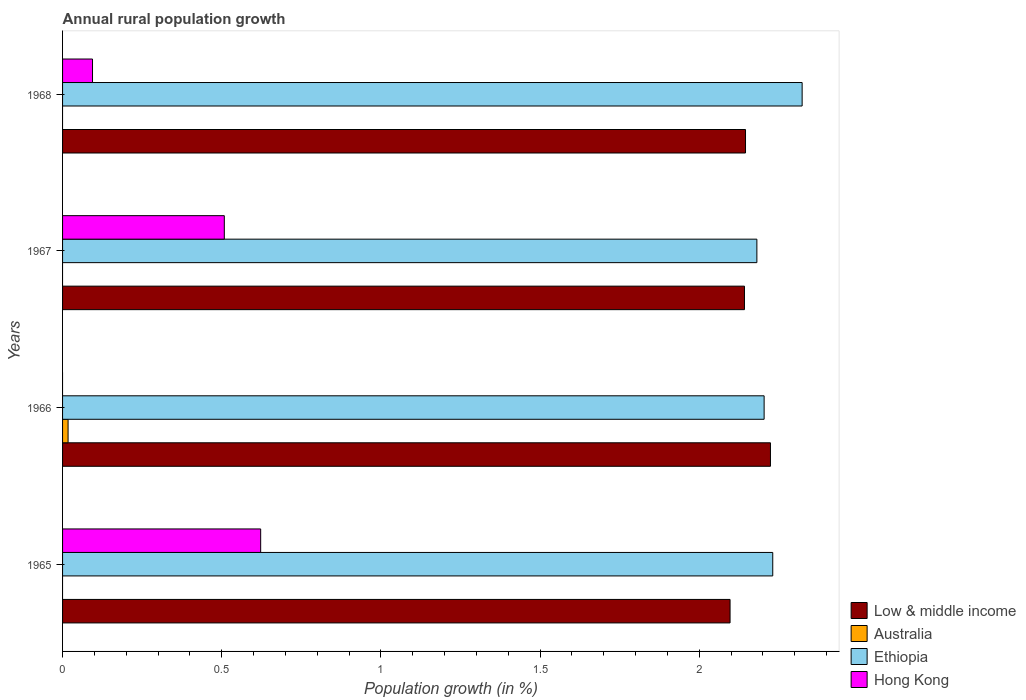How many different coloured bars are there?
Provide a succinct answer. 4. Are the number of bars per tick equal to the number of legend labels?
Offer a terse response. No. Are the number of bars on each tick of the Y-axis equal?
Offer a very short reply. Yes. How many bars are there on the 4th tick from the top?
Your answer should be compact. 3. What is the label of the 3rd group of bars from the top?
Give a very brief answer. 1966. What is the percentage of rural population growth in Ethiopia in 1966?
Give a very brief answer. 2.2. Across all years, what is the maximum percentage of rural population growth in Ethiopia?
Ensure brevity in your answer.  2.32. In which year was the percentage of rural population growth in Australia maximum?
Give a very brief answer. 1966. What is the total percentage of rural population growth in Ethiopia in the graph?
Ensure brevity in your answer.  8.94. What is the difference between the percentage of rural population growth in Low & middle income in 1966 and that in 1968?
Provide a short and direct response. 0.08. What is the difference between the percentage of rural population growth in Hong Kong in 1967 and the percentage of rural population growth in Low & middle income in 1965?
Your response must be concise. -1.59. What is the average percentage of rural population growth in Ethiopia per year?
Offer a very short reply. 2.23. In the year 1968, what is the difference between the percentage of rural population growth in Hong Kong and percentage of rural population growth in Low & middle income?
Ensure brevity in your answer.  -2.05. What is the ratio of the percentage of rural population growth in Hong Kong in 1965 to that in 1968?
Provide a short and direct response. 6.62. What is the difference between the highest and the second highest percentage of rural population growth in Ethiopia?
Your answer should be very brief. 0.09. What is the difference between the highest and the lowest percentage of rural population growth in Hong Kong?
Your response must be concise. 0.62. In how many years, is the percentage of rural population growth in Australia greater than the average percentage of rural population growth in Australia taken over all years?
Ensure brevity in your answer.  1. Is it the case that in every year, the sum of the percentage of rural population growth in Low & middle income and percentage of rural population growth in Ethiopia is greater than the percentage of rural population growth in Hong Kong?
Your response must be concise. Yes. How many years are there in the graph?
Keep it short and to the point. 4. What is the difference between two consecutive major ticks on the X-axis?
Give a very brief answer. 0.5. Does the graph contain any zero values?
Keep it short and to the point. Yes. Where does the legend appear in the graph?
Make the answer very short. Bottom right. How many legend labels are there?
Your response must be concise. 4. What is the title of the graph?
Your answer should be compact. Annual rural population growth. What is the label or title of the X-axis?
Offer a very short reply. Population growth (in %). What is the label or title of the Y-axis?
Your answer should be compact. Years. What is the Population growth (in %) of Low & middle income in 1965?
Your response must be concise. 2.1. What is the Population growth (in %) in Ethiopia in 1965?
Your answer should be very brief. 2.23. What is the Population growth (in %) in Hong Kong in 1965?
Provide a succinct answer. 0.62. What is the Population growth (in %) of Low & middle income in 1966?
Your answer should be compact. 2.22. What is the Population growth (in %) of Australia in 1966?
Your answer should be compact. 0.02. What is the Population growth (in %) in Ethiopia in 1966?
Offer a very short reply. 2.2. What is the Population growth (in %) in Low & middle income in 1967?
Give a very brief answer. 2.14. What is the Population growth (in %) of Australia in 1967?
Keep it short and to the point. 0. What is the Population growth (in %) in Ethiopia in 1967?
Keep it short and to the point. 2.18. What is the Population growth (in %) of Hong Kong in 1967?
Provide a succinct answer. 0.51. What is the Population growth (in %) in Low & middle income in 1968?
Ensure brevity in your answer.  2.15. What is the Population growth (in %) in Australia in 1968?
Give a very brief answer. 0. What is the Population growth (in %) in Ethiopia in 1968?
Offer a very short reply. 2.32. What is the Population growth (in %) of Hong Kong in 1968?
Provide a succinct answer. 0.09. Across all years, what is the maximum Population growth (in %) in Low & middle income?
Offer a very short reply. 2.22. Across all years, what is the maximum Population growth (in %) in Australia?
Keep it short and to the point. 0.02. Across all years, what is the maximum Population growth (in %) in Ethiopia?
Your response must be concise. 2.32. Across all years, what is the maximum Population growth (in %) in Hong Kong?
Offer a terse response. 0.62. Across all years, what is the minimum Population growth (in %) of Low & middle income?
Provide a succinct answer. 2.1. Across all years, what is the minimum Population growth (in %) of Ethiopia?
Your answer should be compact. 2.18. What is the total Population growth (in %) in Low & middle income in the graph?
Ensure brevity in your answer.  8.61. What is the total Population growth (in %) of Australia in the graph?
Keep it short and to the point. 0.02. What is the total Population growth (in %) of Ethiopia in the graph?
Ensure brevity in your answer.  8.94. What is the total Population growth (in %) of Hong Kong in the graph?
Give a very brief answer. 1.22. What is the difference between the Population growth (in %) in Low & middle income in 1965 and that in 1966?
Keep it short and to the point. -0.13. What is the difference between the Population growth (in %) of Ethiopia in 1965 and that in 1966?
Your answer should be very brief. 0.03. What is the difference between the Population growth (in %) in Low & middle income in 1965 and that in 1967?
Offer a very short reply. -0.05. What is the difference between the Population growth (in %) in Ethiopia in 1965 and that in 1967?
Provide a short and direct response. 0.05. What is the difference between the Population growth (in %) in Hong Kong in 1965 and that in 1967?
Offer a very short reply. 0.11. What is the difference between the Population growth (in %) in Low & middle income in 1965 and that in 1968?
Your answer should be compact. -0.05. What is the difference between the Population growth (in %) in Ethiopia in 1965 and that in 1968?
Your response must be concise. -0.09. What is the difference between the Population growth (in %) of Hong Kong in 1965 and that in 1968?
Offer a very short reply. 0.53. What is the difference between the Population growth (in %) of Low & middle income in 1966 and that in 1967?
Offer a terse response. 0.08. What is the difference between the Population growth (in %) of Ethiopia in 1966 and that in 1967?
Provide a short and direct response. 0.02. What is the difference between the Population growth (in %) in Low & middle income in 1966 and that in 1968?
Your answer should be compact. 0.08. What is the difference between the Population growth (in %) of Ethiopia in 1966 and that in 1968?
Your answer should be very brief. -0.12. What is the difference between the Population growth (in %) of Low & middle income in 1967 and that in 1968?
Give a very brief answer. -0. What is the difference between the Population growth (in %) of Ethiopia in 1967 and that in 1968?
Ensure brevity in your answer.  -0.14. What is the difference between the Population growth (in %) in Hong Kong in 1967 and that in 1968?
Give a very brief answer. 0.41. What is the difference between the Population growth (in %) in Low & middle income in 1965 and the Population growth (in %) in Australia in 1966?
Ensure brevity in your answer.  2.08. What is the difference between the Population growth (in %) in Low & middle income in 1965 and the Population growth (in %) in Ethiopia in 1966?
Your response must be concise. -0.11. What is the difference between the Population growth (in %) in Low & middle income in 1965 and the Population growth (in %) in Ethiopia in 1967?
Provide a short and direct response. -0.08. What is the difference between the Population growth (in %) in Low & middle income in 1965 and the Population growth (in %) in Hong Kong in 1967?
Your answer should be very brief. 1.59. What is the difference between the Population growth (in %) of Ethiopia in 1965 and the Population growth (in %) of Hong Kong in 1967?
Keep it short and to the point. 1.72. What is the difference between the Population growth (in %) of Low & middle income in 1965 and the Population growth (in %) of Ethiopia in 1968?
Provide a succinct answer. -0.23. What is the difference between the Population growth (in %) in Low & middle income in 1965 and the Population growth (in %) in Hong Kong in 1968?
Make the answer very short. 2. What is the difference between the Population growth (in %) of Ethiopia in 1965 and the Population growth (in %) of Hong Kong in 1968?
Your response must be concise. 2.14. What is the difference between the Population growth (in %) of Low & middle income in 1966 and the Population growth (in %) of Ethiopia in 1967?
Your answer should be compact. 0.04. What is the difference between the Population growth (in %) of Low & middle income in 1966 and the Population growth (in %) of Hong Kong in 1967?
Provide a succinct answer. 1.72. What is the difference between the Population growth (in %) of Australia in 1966 and the Population growth (in %) of Ethiopia in 1967?
Your answer should be very brief. -2.16. What is the difference between the Population growth (in %) of Australia in 1966 and the Population growth (in %) of Hong Kong in 1967?
Your answer should be compact. -0.49. What is the difference between the Population growth (in %) of Ethiopia in 1966 and the Population growth (in %) of Hong Kong in 1967?
Your answer should be compact. 1.7. What is the difference between the Population growth (in %) in Low & middle income in 1966 and the Population growth (in %) in Ethiopia in 1968?
Make the answer very short. -0.1. What is the difference between the Population growth (in %) of Low & middle income in 1966 and the Population growth (in %) of Hong Kong in 1968?
Make the answer very short. 2.13. What is the difference between the Population growth (in %) of Australia in 1966 and the Population growth (in %) of Ethiopia in 1968?
Ensure brevity in your answer.  -2.31. What is the difference between the Population growth (in %) of Australia in 1966 and the Population growth (in %) of Hong Kong in 1968?
Offer a very short reply. -0.08. What is the difference between the Population growth (in %) of Ethiopia in 1966 and the Population growth (in %) of Hong Kong in 1968?
Your response must be concise. 2.11. What is the difference between the Population growth (in %) of Low & middle income in 1967 and the Population growth (in %) of Ethiopia in 1968?
Your answer should be very brief. -0.18. What is the difference between the Population growth (in %) of Low & middle income in 1967 and the Population growth (in %) of Hong Kong in 1968?
Your answer should be compact. 2.05. What is the difference between the Population growth (in %) of Ethiopia in 1967 and the Population growth (in %) of Hong Kong in 1968?
Keep it short and to the point. 2.09. What is the average Population growth (in %) of Low & middle income per year?
Make the answer very short. 2.15. What is the average Population growth (in %) of Australia per year?
Offer a very short reply. 0. What is the average Population growth (in %) in Ethiopia per year?
Offer a terse response. 2.23. What is the average Population growth (in %) of Hong Kong per year?
Make the answer very short. 0.31. In the year 1965, what is the difference between the Population growth (in %) of Low & middle income and Population growth (in %) of Ethiopia?
Your response must be concise. -0.13. In the year 1965, what is the difference between the Population growth (in %) in Low & middle income and Population growth (in %) in Hong Kong?
Make the answer very short. 1.47. In the year 1965, what is the difference between the Population growth (in %) in Ethiopia and Population growth (in %) in Hong Kong?
Ensure brevity in your answer.  1.61. In the year 1966, what is the difference between the Population growth (in %) of Low & middle income and Population growth (in %) of Australia?
Your answer should be compact. 2.21. In the year 1966, what is the difference between the Population growth (in %) in Low & middle income and Population growth (in %) in Ethiopia?
Provide a succinct answer. 0.02. In the year 1966, what is the difference between the Population growth (in %) in Australia and Population growth (in %) in Ethiopia?
Your answer should be very brief. -2.19. In the year 1967, what is the difference between the Population growth (in %) in Low & middle income and Population growth (in %) in Ethiopia?
Offer a very short reply. -0.04. In the year 1967, what is the difference between the Population growth (in %) of Low & middle income and Population growth (in %) of Hong Kong?
Your response must be concise. 1.63. In the year 1967, what is the difference between the Population growth (in %) in Ethiopia and Population growth (in %) in Hong Kong?
Ensure brevity in your answer.  1.67. In the year 1968, what is the difference between the Population growth (in %) of Low & middle income and Population growth (in %) of Ethiopia?
Your response must be concise. -0.18. In the year 1968, what is the difference between the Population growth (in %) in Low & middle income and Population growth (in %) in Hong Kong?
Your response must be concise. 2.05. In the year 1968, what is the difference between the Population growth (in %) of Ethiopia and Population growth (in %) of Hong Kong?
Offer a terse response. 2.23. What is the ratio of the Population growth (in %) of Low & middle income in 1965 to that in 1966?
Ensure brevity in your answer.  0.94. What is the ratio of the Population growth (in %) in Ethiopia in 1965 to that in 1966?
Ensure brevity in your answer.  1.01. What is the ratio of the Population growth (in %) of Low & middle income in 1965 to that in 1967?
Ensure brevity in your answer.  0.98. What is the ratio of the Population growth (in %) in Ethiopia in 1965 to that in 1967?
Make the answer very short. 1.02. What is the ratio of the Population growth (in %) of Hong Kong in 1965 to that in 1967?
Your response must be concise. 1.22. What is the ratio of the Population growth (in %) of Low & middle income in 1965 to that in 1968?
Offer a very short reply. 0.98. What is the ratio of the Population growth (in %) of Ethiopia in 1965 to that in 1968?
Make the answer very short. 0.96. What is the ratio of the Population growth (in %) in Hong Kong in 1965 to that in 1968?
Offer a very short reply. 6.62. What is the ratio of the Population growth (in %) of Low & middle income in 1966 to that in 1967?
Make the answer very short. 1.04. What is the ratio of the Population growth (in %) of Ethiopia in 1966 to that in 1967?
Your answer should be compact. 1.01. What is the ratio of the Population growth (in %) of Low & middle income in 1966 to that in 1968?
Keep it short and to the point. 1.04. What is the ratio of the Population growth (in %) of Ethiopia in 1966 to that in 1968?
Your answer should be very brief. 0.95. What is the ratio of the Population growth (in %) of Ethiopia in 1967 to that in 1968?
Keep it short and to the point. 0.94. What is the ratio of the Population growth (in %) in Hong Kong in 1967 to that in 1968?
Ensure brevity in your answer.  5.4. What is the difference between the highest and the second highest Population growth (in %) of Low & middle income?
Your response must be concise. 0.08. What is the difference between the highest and the second highest Population growth (in %) of Ethiopia?
Provide a succinct answer. 0.09. What is the difference between the highest and the second highest Population growth (in %) in Hong Kong?
Provide a succinct answer. 0.11. What is the difference between the highest and the lowest Population growth (in %) of Low & middle income?
Provide a succinct answer. 0.13. What is the difference between the highest and the lowest Population growth (in %) of Australia?
Your answer should be very brief. 0.02. What is the difference between the highest and the lowest Population growth (in %) in Ethiopia?
Ensure brevity in your answer.  0.14. What is the difference between the highest and the lowest Population growth (in %) in Hong Kong?
Offer a very short reply. 0.62. 